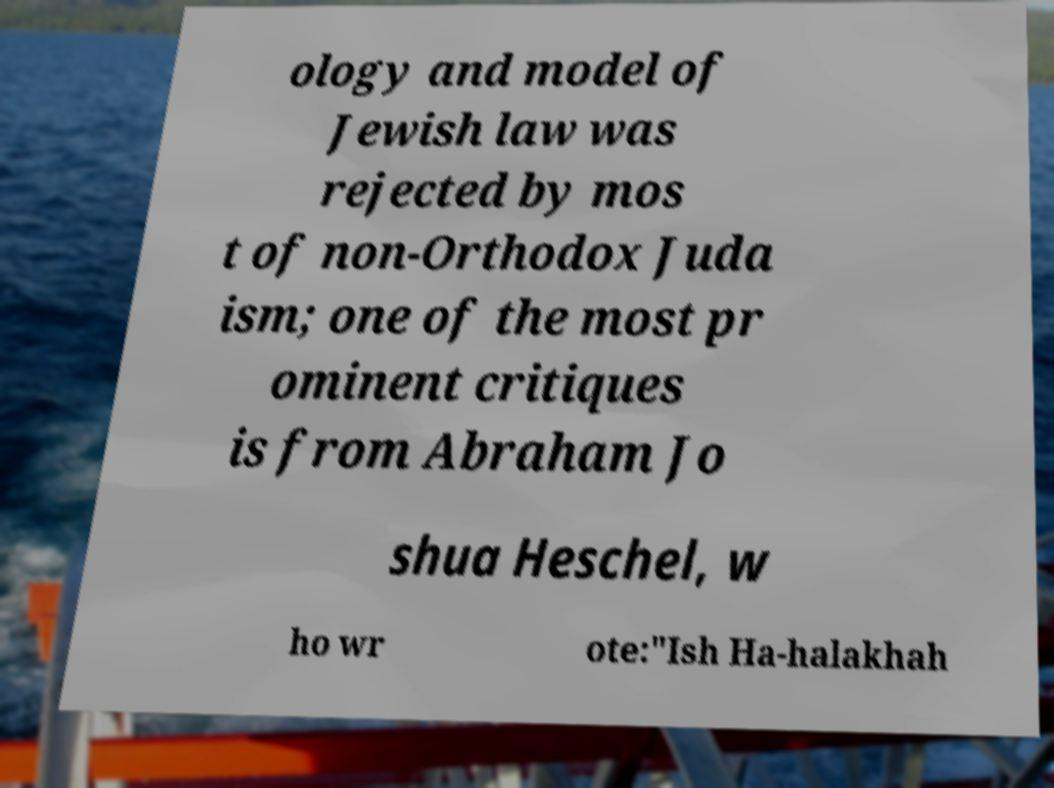For documentation purposes, I need the text within this image transcribed. Could you provide that? ology and model of Jewish law was rejected by mos t of non-Orthodox Juda ism; one of the most pr ominent critiques is from Abraham Jo shua Heschel, w ho wr ote:"Ish Ha-halakhah 